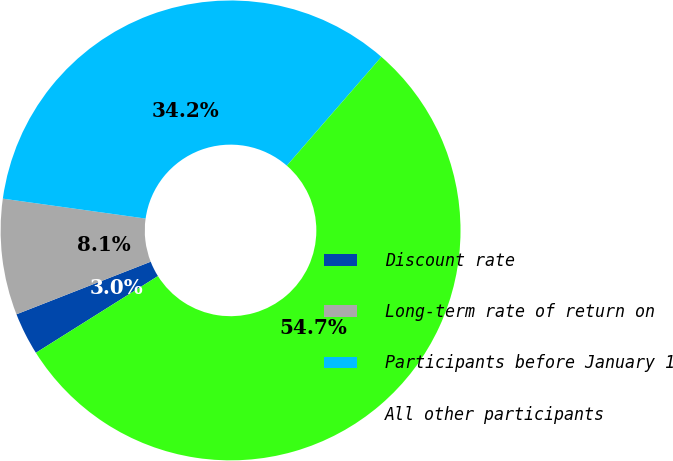Convert chart. <chart><loc_0><loc_0><loc_500><loc_500><pie_chart><fcel>Discount rate<fcel>Long-term rate of return on<fcel>Participants before January 1<fcel>All other participants<nl><fcel>2.99%<fcel>8.15%<fcel>34.18%<fcel>54.68%<nl></chart> 